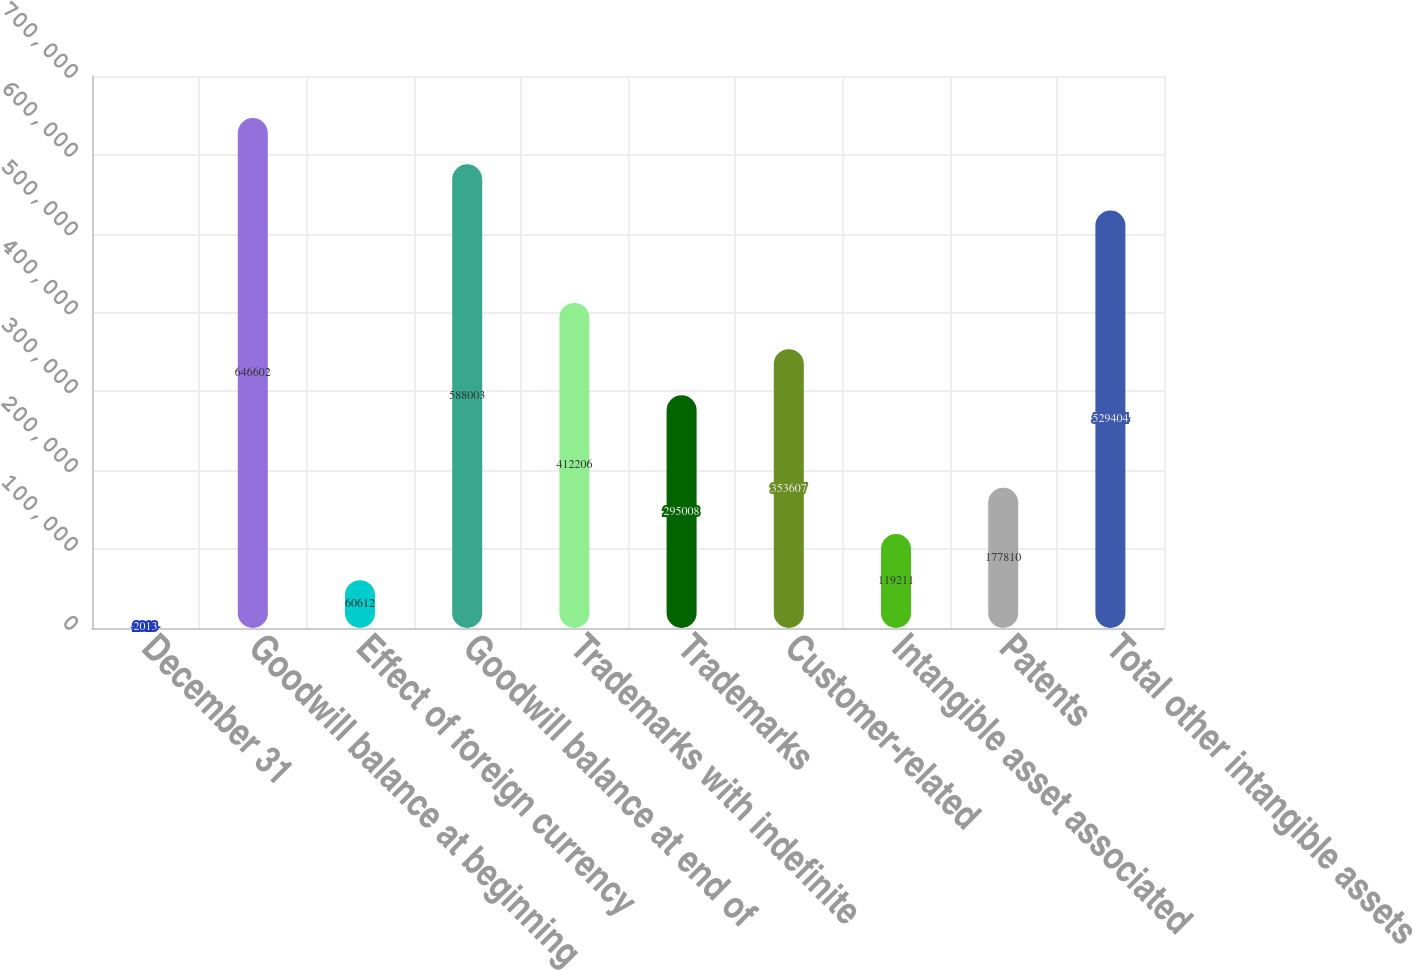Convert chart to OTSL. <chart><loc_0><loc_0><loc_500><loc_500><bar_chart><fcel>December 31<fcel>Goodwill balance at beginning<fcel>Effect of foreign currency<fcel>Goodwill balance at end of<fcel>Trademarks with indefinite<fcel>Trademarks<fcel>Customer-related<fcel>Intangible asset associated<fcel>Patents<fcel>Total other intangible assets<nl><fcel>2013<fcel>646602<fcel>60612<fcel>588003<fcel>412206<fcel>295008<fcel>353607<fcel>119211<fcel>177810<fcel>529404<nl></chart> 